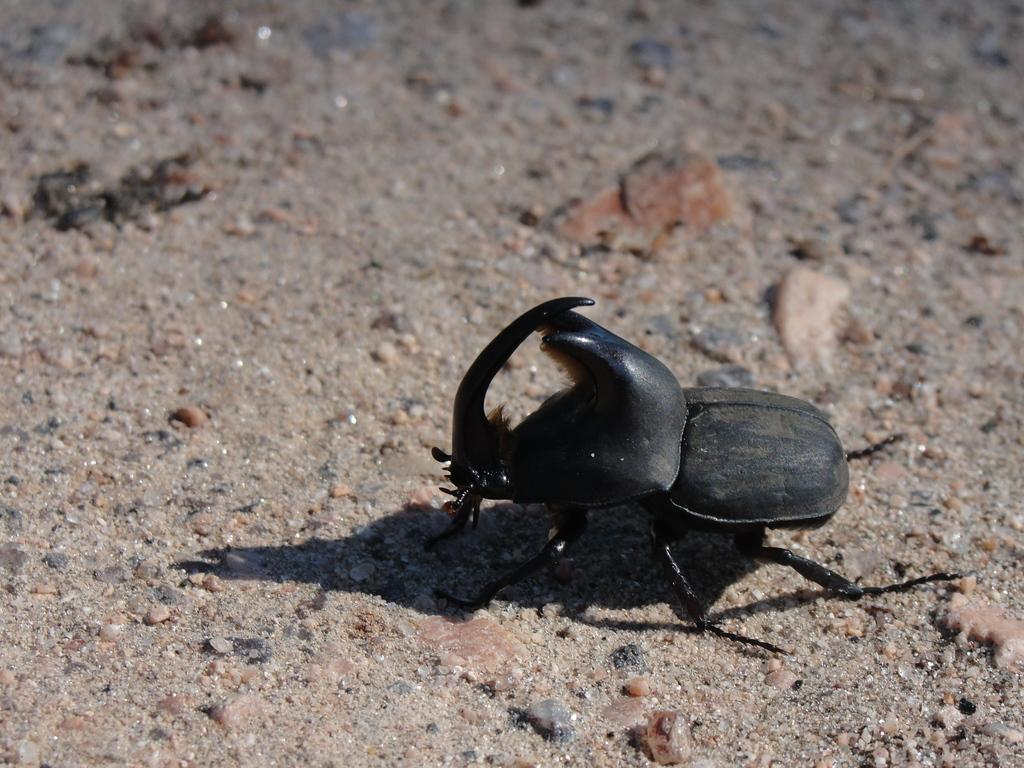What type of creature is present in the image? There is an insect in the image. Where is the insect located in the image? The insect is in the front of the image. What can be seen at the bottom of the image? There are stones at the bottom of the image. What type of guide is the insect providing in the image? There is no indication in the image that the insect is providing any guidance. 